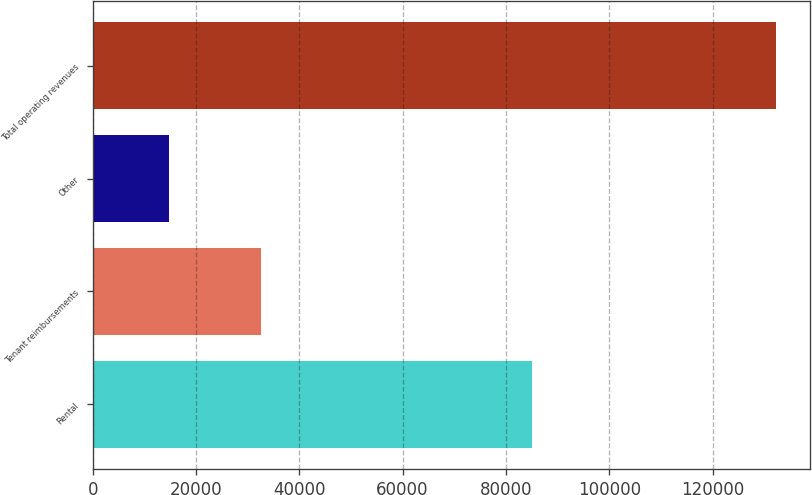<chart> <loc_0><loc_0><loc_500><loc_500><bar_chart><fcel>Rental<fcel>Tenant reimbursements<fcel>Other<fcel>Total operating revenues<nl><fcel>84956<fcel>32500<fcel>14742<fcel>132198<nl></chart> 